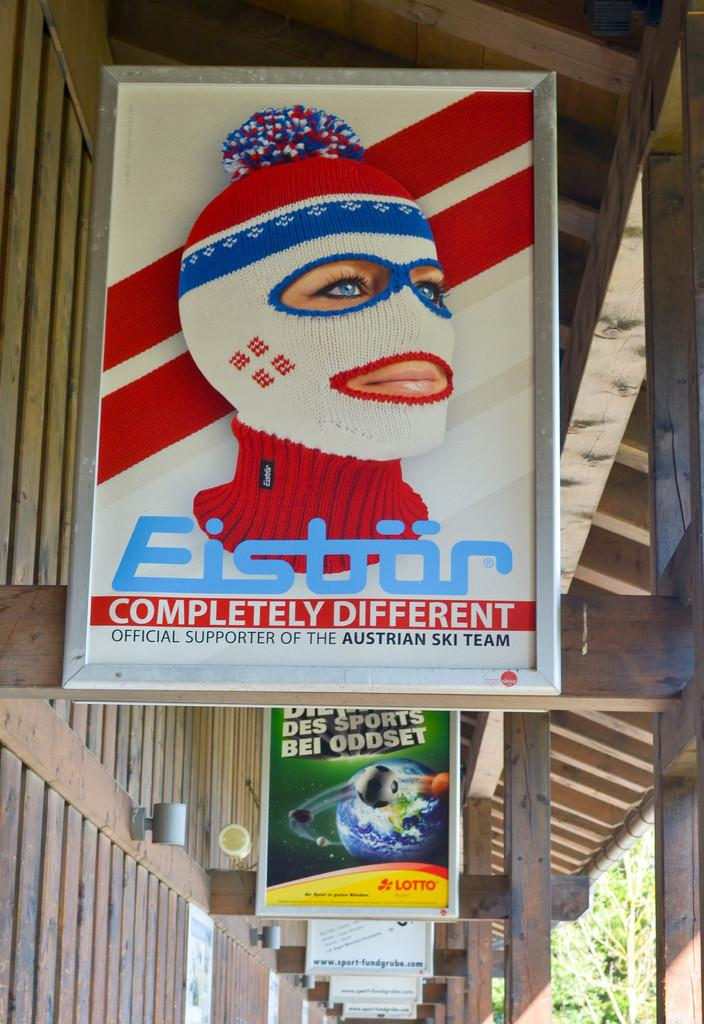<image>
Create a compact narrative representing the image presented. A sign for Eistor that says Completely Different. 